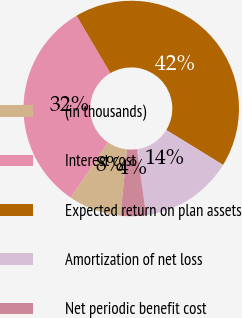Convert chart to OTSL. <chart><loc_0><loc_0><loc_500><loc_500><pie_chart><fcel>(in thousands)<fcel>Interest cost<fcel>Expected return on plan assets<fcel>Amortization of net loss<fcel>Net periodic benefit cost<nl><fcel>7.89%<fcel>32.03%<fcel>42.24%<fcel>14.02%<fcel>3.81%<nl></chart> 